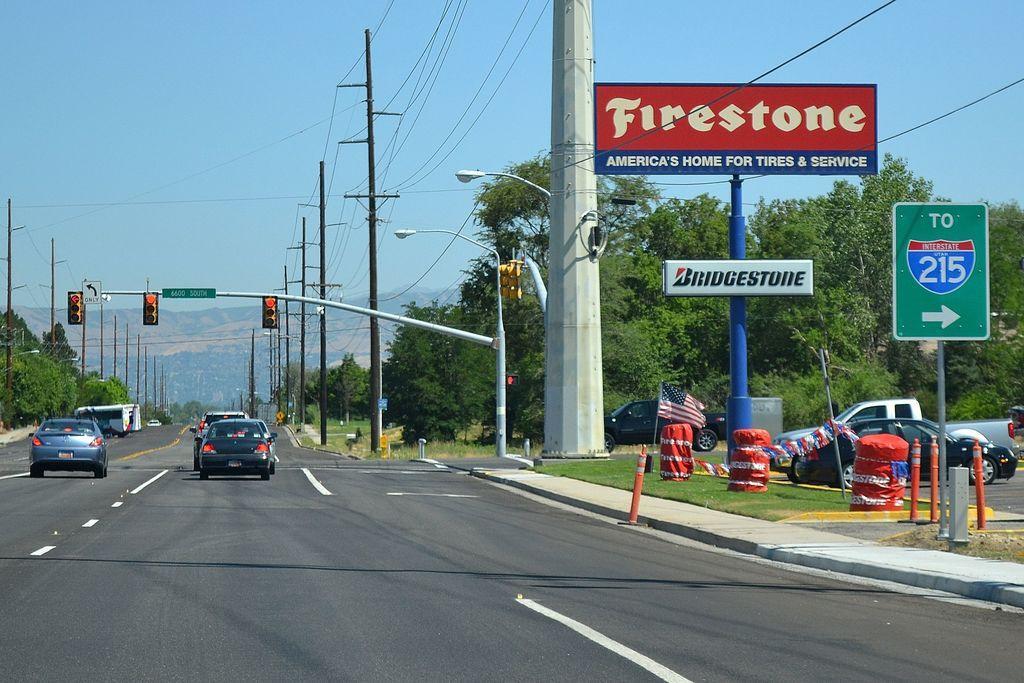Please provide a concise description of this image. This image is clicked on the road. There are vehicles moving on the road. There are electric poles, traffic signal poles and street light poles on the walkway. To the right there are cars on the road. In front of the cars there are drums, a flag, sign board poles and grass on the ground. In the background there are trees and mountains. At the top there is the sky. 